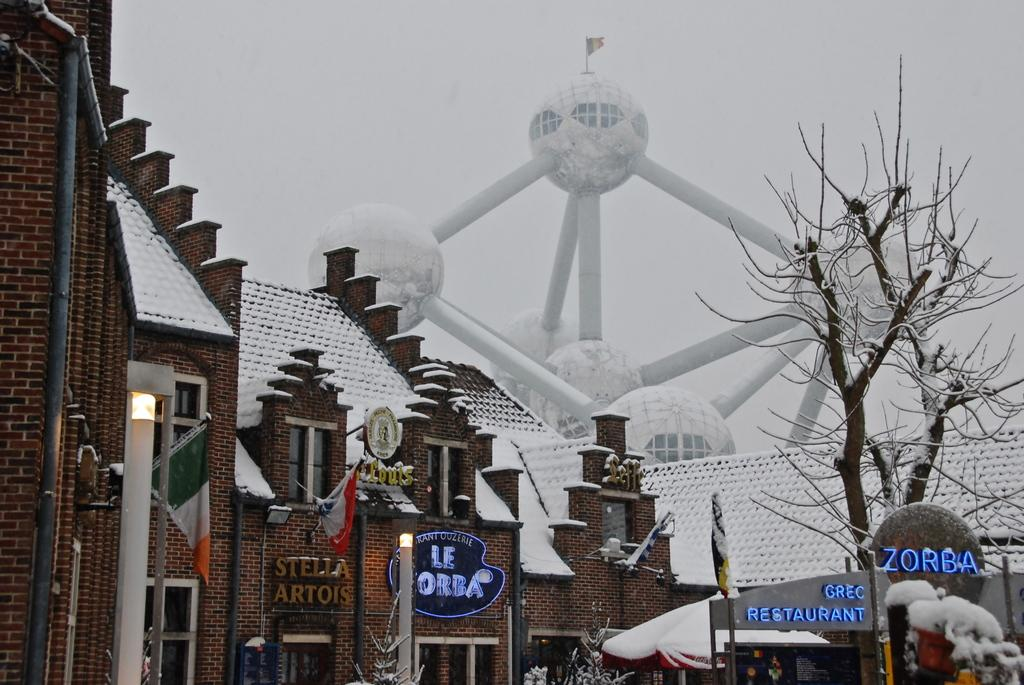What type of structures are present in the image? There are buildings in the image. What is covering the buildings in the image? The buildings have snow on them. What type of vegetation can be seen on the right side of the image? There are trees to the right of the image. What is visible at the top of the image? The sky is visible at the top of the image. Can you tell me how many alarms are going off in the image? There are no alarms present in the image; it only features buildings with snow, trees, and a visible sky. 